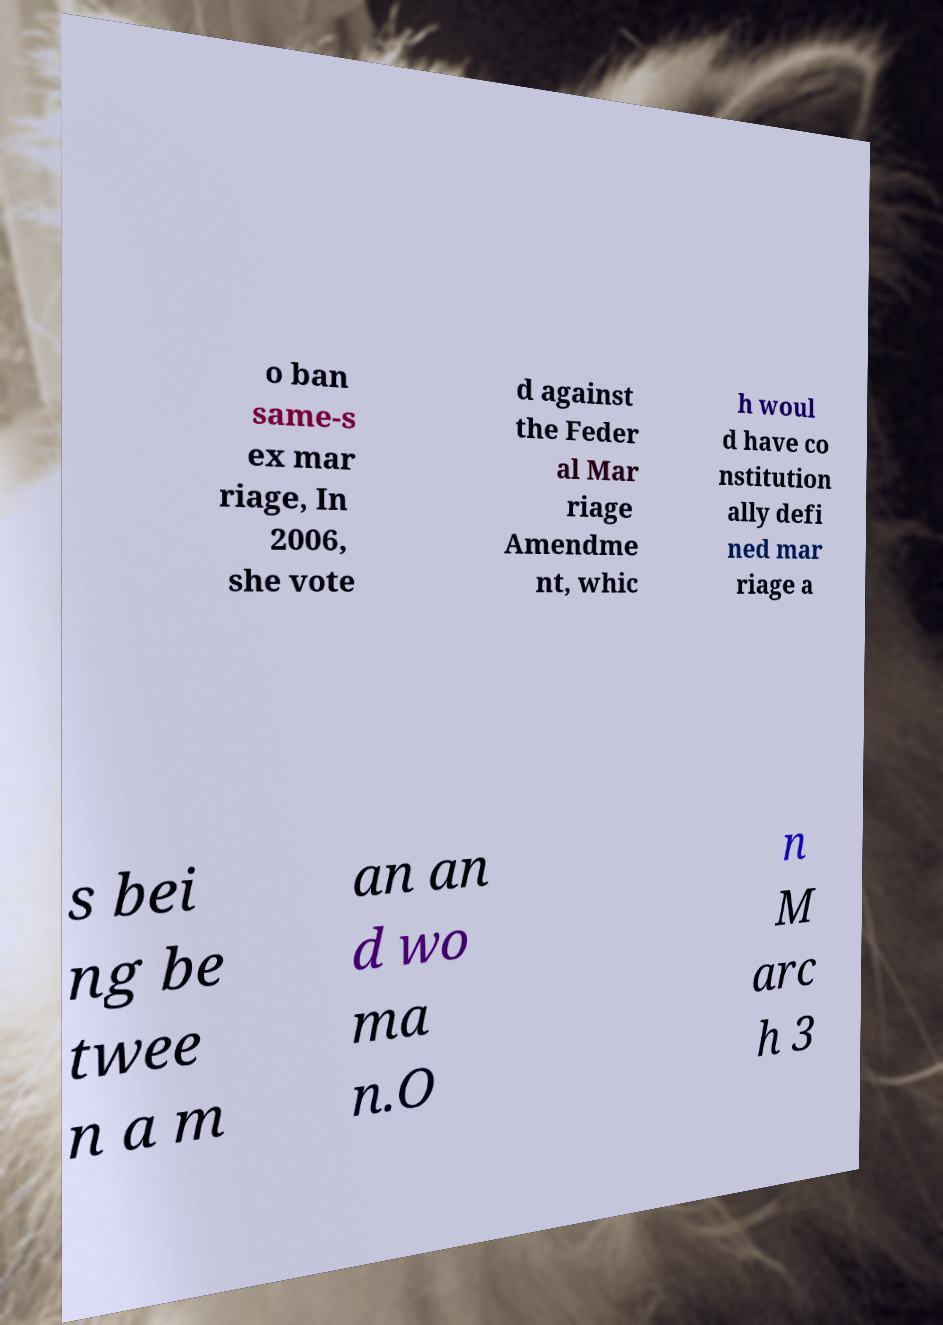Can you read and provide the text displayed in the image?This photo seems to have some interesting text. Can you extract and type it out for me? o ban same-s ex mar riage, In 2006, she vote d against the Feder al Mar riage Amendme nt, whic h woul d have co nstitution ally defi ned mar riage a s bei ng be twee n a m an an d wo ma n.O n M arc h 3 